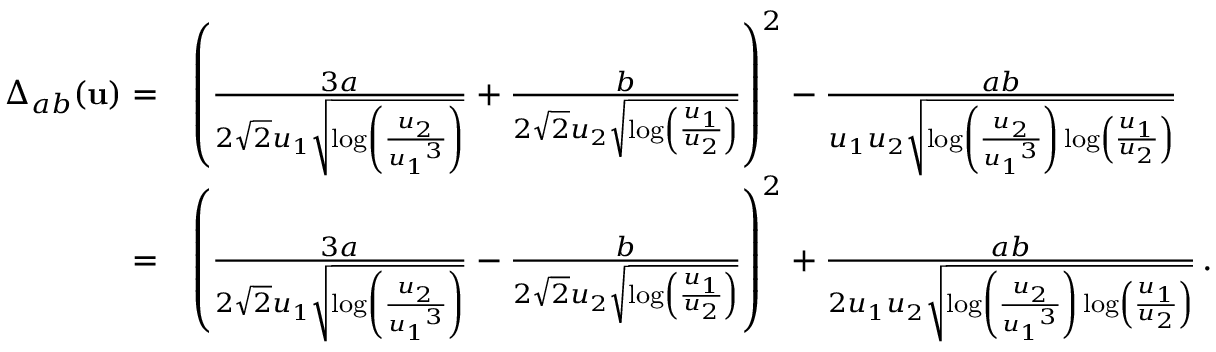<formula> <loc_0><loc_0><loc_500><loc_500>\begin{array} { r l } { \Delta _ { a b } ( { u } ) = } & { \left ( \frac { 3 a } { 2 \sqrt { 2 } { u _ { 1 } } \sqrt { \log \left ( \frac { { u _ { 2 } } } { { u _ { 1 } } ^ { 3 } } \right ) } } + \frac { b } { 2 \sqrt { 2 } { u _ { 2 } } \sqrt { \log \left ( \frac { { u _ { 1 } } } { { u _ { 2 } } } \right ) } } \right ) ^ { 2 } - \frac { a b } { { u _ { 1 } u _ { 2 } } \sqrt { \log \left ( \frac { { u _ { 2 } } } { { u _ { 1 } } ^ { 3 } } \right ) \log \left ( \frac { { u _ { 1 } } } { { u _ { 2 } } } \right ) } } } \\ { = } & { \left ( \frac { 3 a } { 2 \sqrt { 2 } { u _ { 1 } } \sqrt { \log \left ( \frac { { u _ { 2 } } } { { u _ { 1 } } ^ { 3 } } \right ) } } - \frac { b } { 2 \sqrt { 2 } { u _ { 2 } } \sqrt { \log \left ( \frac { { u _ { 1 } } } { { u _ { 2 } } } \right ) } } \right ) ^ { 2 } + \frac { a b } { { 2 u _ { 1 } u _ { 2 } } \sqrt { \log \left ( \frac { { u _ { 2 } } } { { u _ { 1 } } ^ { 3 } } \right ) \log \left ( \frac { { u _ { 1 } } } { { u _ { 2 } } } \right ) } } \, . } \end{array}</formula> 